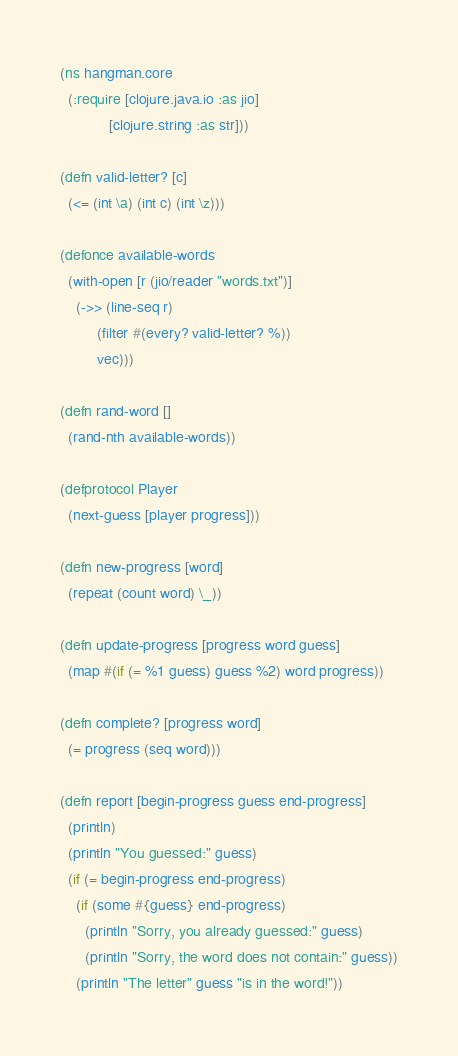Convert code to text. <code><loc_0><loc_0><loc_500><loc_500><_Clojure_>(ns hangman.core
  (:require [clojure.java.io :as jio]
            [clojure.string :as str]))

(defn valid-letter? [c]
  (<= (int \a) (int c) (int \z)))

(defonce available-words
  (with-open [r (jio/reader "words.txt")]
    (->> (line-seq r)
         (filter #(every? valid-letter? %))
         vec)))

(defn rand-word []
  (rand-nth available-words))

(defprotocol Player
  (next-guess [player progress]))

(defn new-progress [word]
  (repeat (count word) \_))

(defn update-progress [progress word guess]
  (map #(if (= %1 guess) guess %2) word progress))

(defn complete? [progress word]
  (= progress (seq word)))

(defn report [begin-progress guess end-progress]
  (println)
  (println "You guessed:" guess)
  (if (= begin-progress end-progress)
    (if (some #{guess} end-progress)
      (println "Sorry, you already guessed:" guess)
      (println "Sorry, the word does not contain:" guess))
    (println "The letter" guess "is in the word!"))</code> 